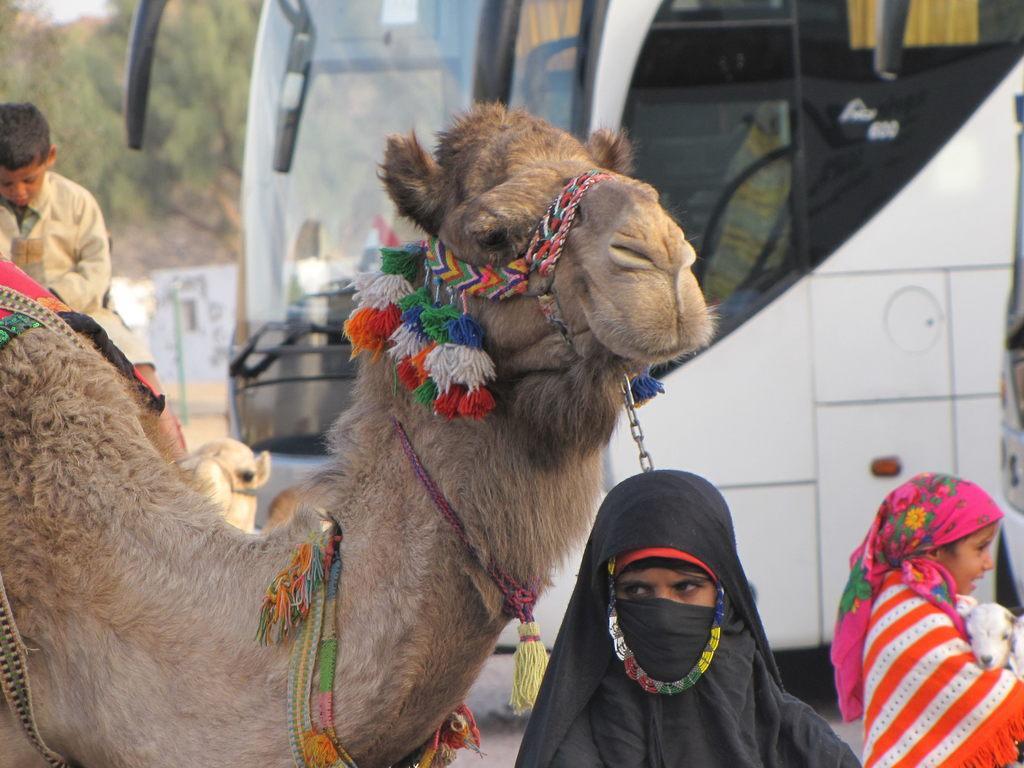Describe this image in one or two sentences. In the picture I can see people, camels and a bus. In the background I can see trees. 